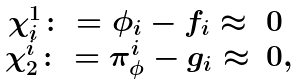<formula> <loc_0><loc_0><loc_500><loc_500>\begin{array} { r c l } & \chi ^ { 1 } _ { i } \colon = \phi _ { i } - f _ { i } \approx & 0 \\ & \chi ^ { i } _ { 2 } \colon = \pi _ { \phi } ^ { i } - g _ { i } \approx & 0 , \end{array}</formula> 